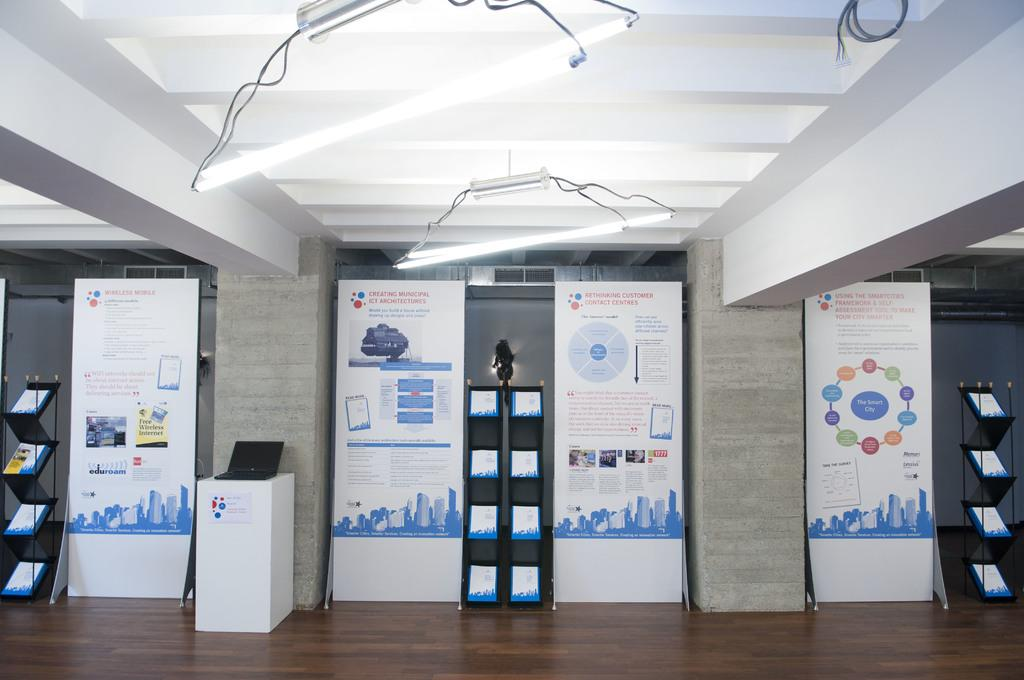What objects can be seen in the image that are made of wood or a similar material? There are boards in the image. What electronic device is placed on a white color box in the image? There is a laptop on a white color box in the image. Where are the books located in the image? The books are in a rack in the image. What can be seen in the background of the image that provides illumination? There are lights visible in the background of the image. What type of alarm is being sounded by the army in the image? There is no army or alarm present in the image; it only features boards, a laptop, books, and lights. 